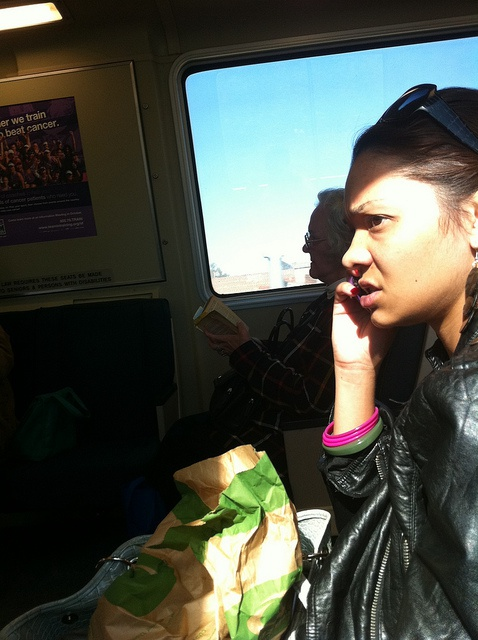Describe the objects in this image and their specific colors. I can see people in black, beige, gray, and tan tones, handbag in black, beige, khaki, and olive tones, people in black and ivory tones, handbag in black and gray tones, and book in black and purple tones in this image. 